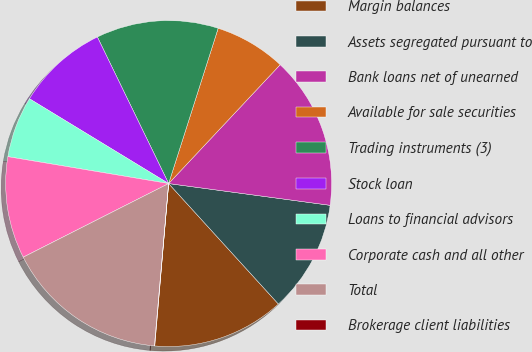<chart> <loc_0><loc_0><loc_500><loc_500><pie_chart><fcel>Margin balances<fcel>Assets segregated pursuant to<fcel>Bank loans net of unearned<fcel>Available for sale securities<fcel>Trading instruments (3)<fcel>Stock loan<fcel>Loans to financial advisors<fcel>Corporate cash and all other<fcel>Total<fcel>Brokerage client liabilities<nl><fcel>13.12%<fcel>11.11%<fcel>15.14%<fcel>7.08%<fcel>12.12%<fcel>9.09%<fcel>6.07%<fcel>10.1%<fcel>16.15%<fcel>0.03%<nl></chart> 